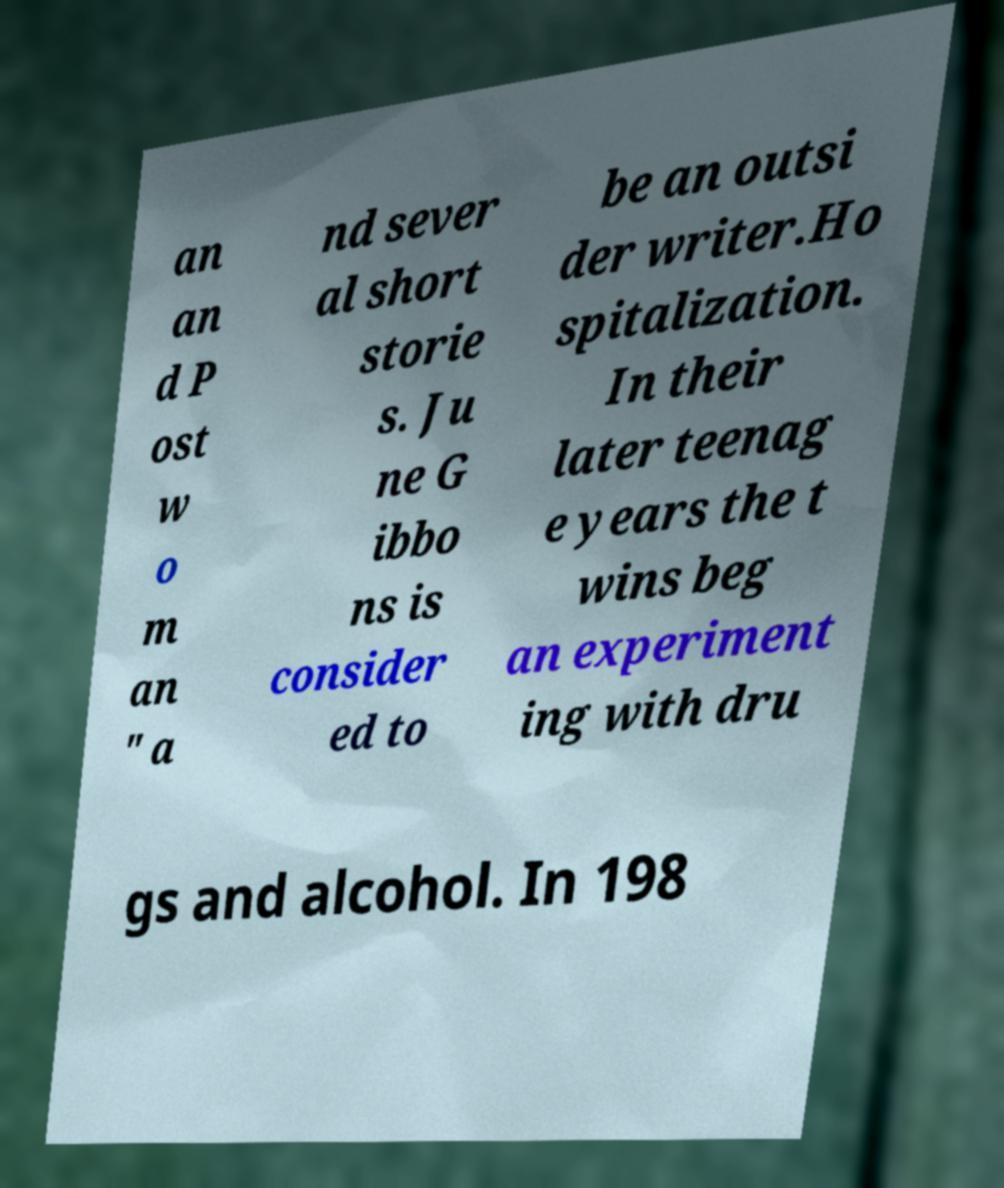What messages or text are displayed in this image? I need them in a readable, typed format. an an d P ost w o m an " a nd sever al short storie s. Ju ne G ibbo ns is consider ed to be an outsi der writer.Ho spitalization. In their later teenag e years the t wins beg an experiment ing with dru gs and alcohol. In 198 